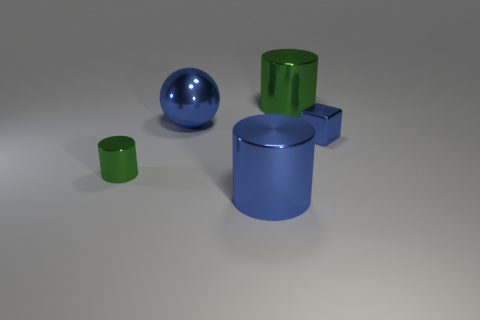Add 2 large green cylinders. How many objects exist? 7 Subtract all cylinders. How many objects are left? 2 Add 1 big blue objects. How many big blue objects exist? 3 Subtract 1 blue balls. How many objects are left? 4 Subtract all blue metal things. Subtract all brown spheres. How many objects are left? 2 Add 4 tiny blue objects. How many tiny blue objects are left? 5 